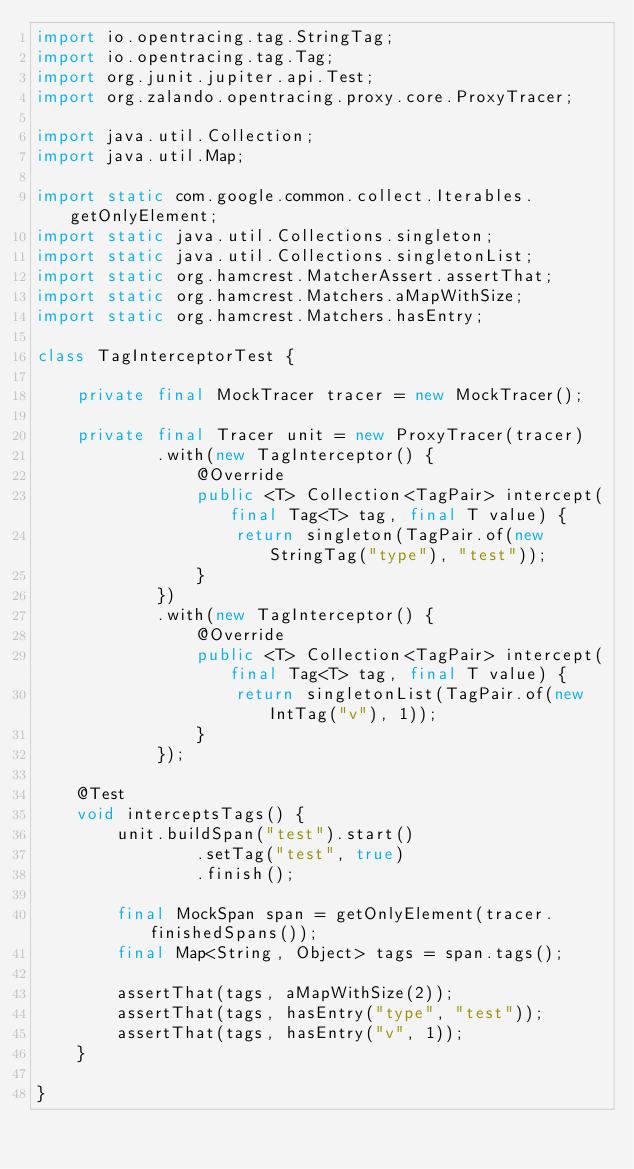Convert code to text. <code><loc_0><loc_0><loc_500><loc_500><_Java_>import io.opentracing.tag.StringTag;
import io.opentracing.tag.Tag;
import org.junit.jupiter.api.Test;
import org.zalando.opentracing.proxy.core.ProxyTracer;

import java.util.Collection;
import java.util.Map;

import static com.google.common.collect.Iterables.getOnlyElement;
import static java.util.Collections.singleton;
import static java.util.Collections.singletonList;
import static org.hamcrest.MatcherAssert.assertThat;
import static org.hamcrest.Matchers.aMapWithSize;
import static org.hamcrest.Matchers.hasEntry;

class TagInterceptorTest {

    private final MockTracer tracer = new MockTracer();

    private final Tracer unit = new ProxyTracer(tracer)
            .with(new TagInterceptor() {
                @Override
                public <T> Collection<TagPair> intercept(final Tag<T> tag, final T value) {
                    return singleton(TagPair.of(new StringTag("type"), "test"));
                }
            })
            .with(new TagInterceptor() {
                @Override
                public <T> Collection<TagPair> intercept(final Tag<T> tag, final T value) {
                    return singletonList(TagPair.of(new IntTag("v"), 1));
                }
            });

    @Test
    void interceptsTags() {
        unit.buildSpan("test").start()
                .setTag("test", true)
                .finish();

        final MockSpan span = getOnlyElement(tracer.finishedSpans());
        final Map<String, Object> tags = span.tags();

        assertThat(tags, aMapWithSize(2));
        assertThat(tags, hasEntry("type", "test"));
        assertThat(tags, hasEntry("v", 1));
    }

}
</code> 